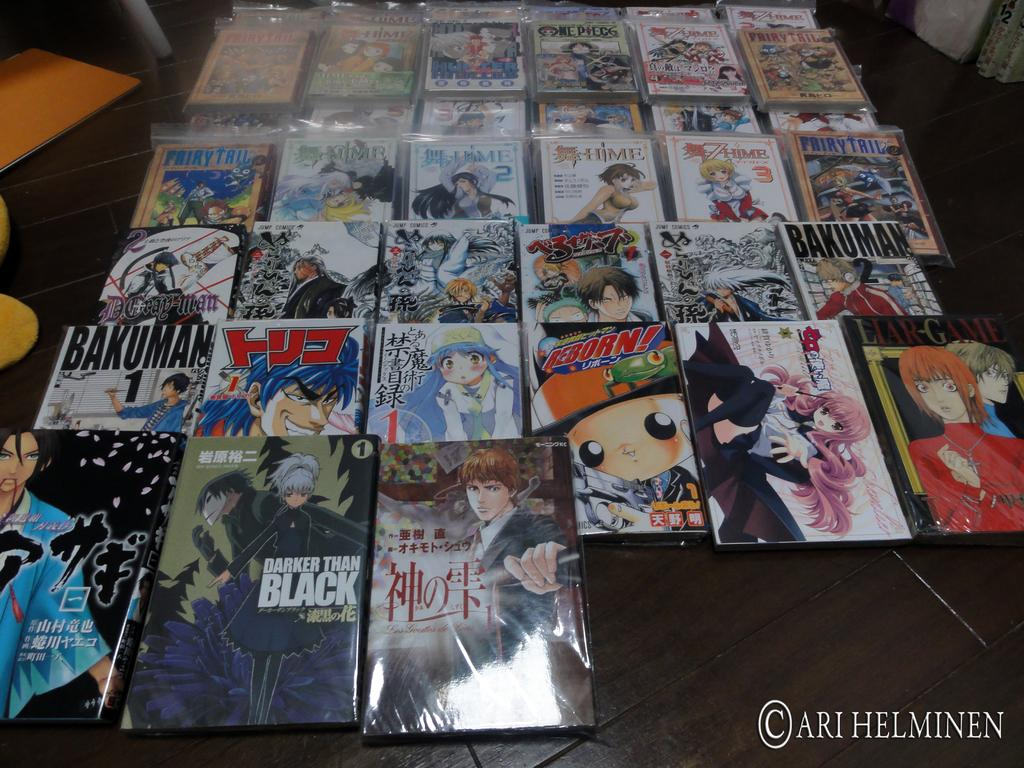<image>
Describe the image concisely. A table with many Manga books in plastic, like Darker Than Black, Bakuman 1, and Liar-Game. 